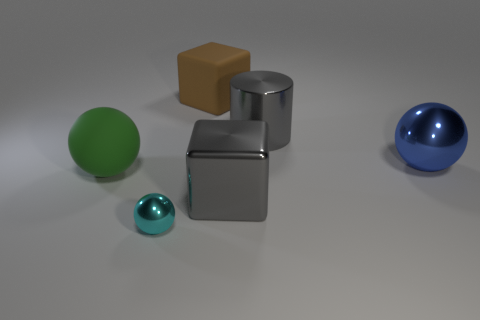Subtract all large balls. How many balls are left? 1 Add 3 purple shiny objects. How many objects exist? 9 Subtract all blocks. How many objects are left? 4 Subtract all large green rubber objects. Subtract all tiny brown shiny blocks. How many objects are left? 5 Add 3 large things. How many large things are left? 8 Add 4 brown matte blocks. How many brown matte blocks exist? 5 Subtract 0 red cylinders. How many objects are left? 6 Subtract all cyan cubes. Subtract all gray cylinders. How many cubes are left? 2 